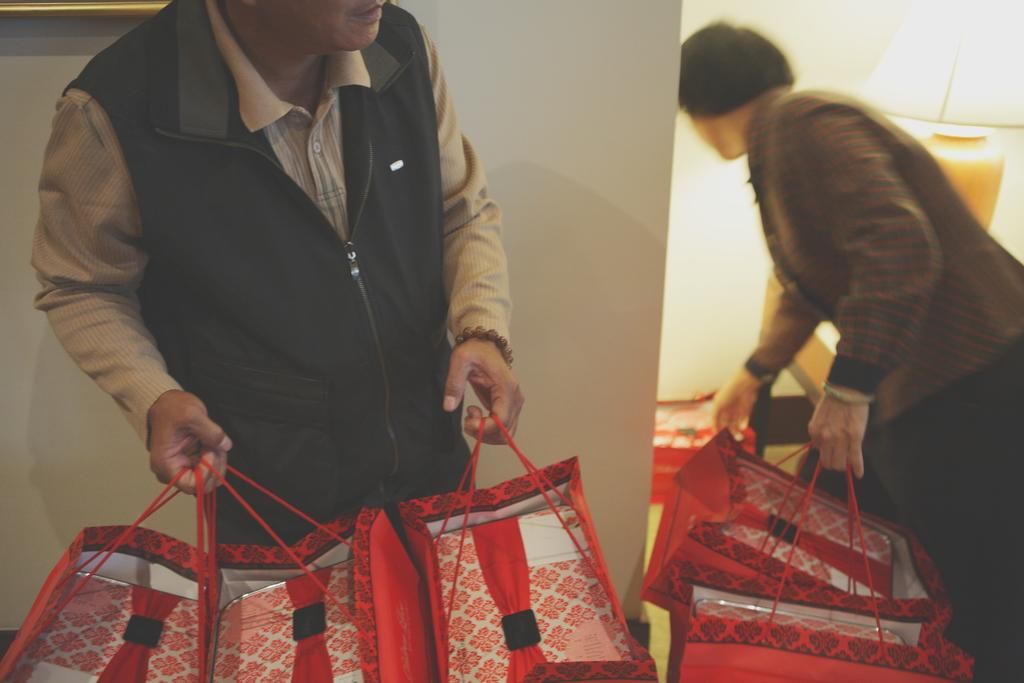What type of space is depicted in the image? The image shows the inner view of a room. How many people are present in the room? There are two persons in the room. What are the persons holding in their hands? The persons are holding bags in their hands. Can you describe any lighting fixtures in the image? Yes, there is a lamp on the right side of the image}. What type of cart can be seen in the image? There is no cart present in the image. What effect does the cannon have on the room in the image? There is no cannon present in the image, so it cannot have any effect on the room. 